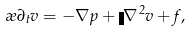<formula> <loc_0><loc_0><loc_500><loc_500>\rho \partial _ { t } { v } = - \nabla p + \eta \nabla ^ { 2 } { v } + { f } ,</formula> 